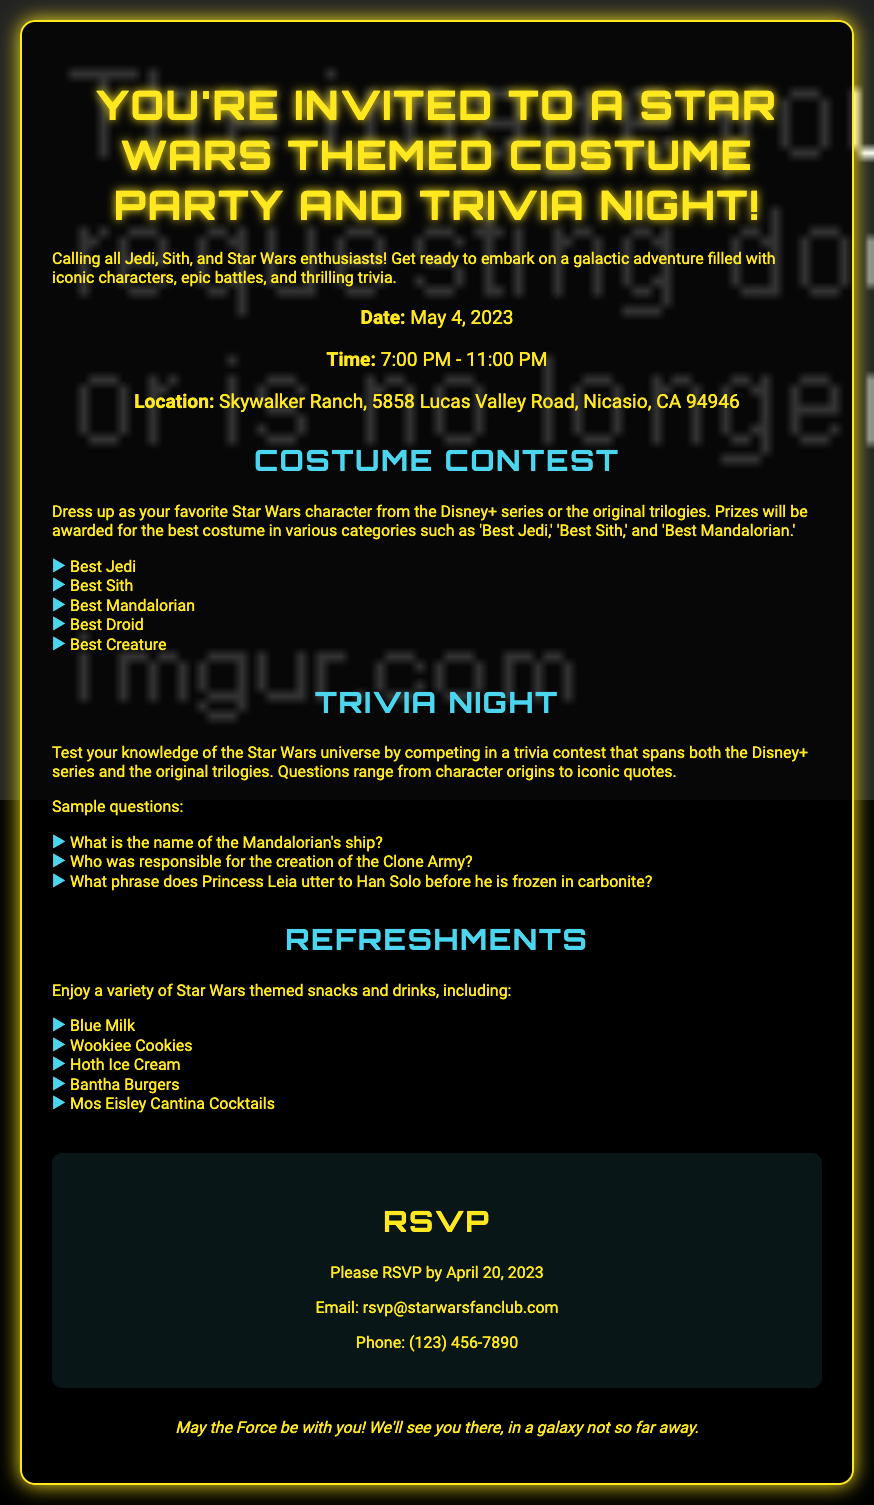What is the date of the event? The date is explicitly stated in the document under event details.
Answer: May 4, 2023 What time does the party start? The starting time is mentioned in the event details section of the document.
Answer: 7:00 PM Where is the location of the party? The location is specified in the event details part of the document.
Answer: Skywalker Ranch, 5858 Lucas Valley Road, Nicasio, CA 94946 What is one of the sample trivia questions? The document lists sample trivia questions under the trivia section, any of them can be used as an answer.
Answer: What is the name of the Mandalorian's ship? How many categories are there in the costume contest? The number of categories can be counted in the activities section of the document.
Answer: Five What is one of the refreshments mentioned? The document lists themed snacks and drinks under the refreshments section, any of them can be used as an answer.
Answer: Blue Milk By what date should attendees RSVP? The RSVP date is clearly stated in the RSVP section of the document.
Answer: April 20, 2023 What phrase is used to conclude the invitation? The concluding statement is located in the footer section of the document.
Answer: May the Force be with you! 